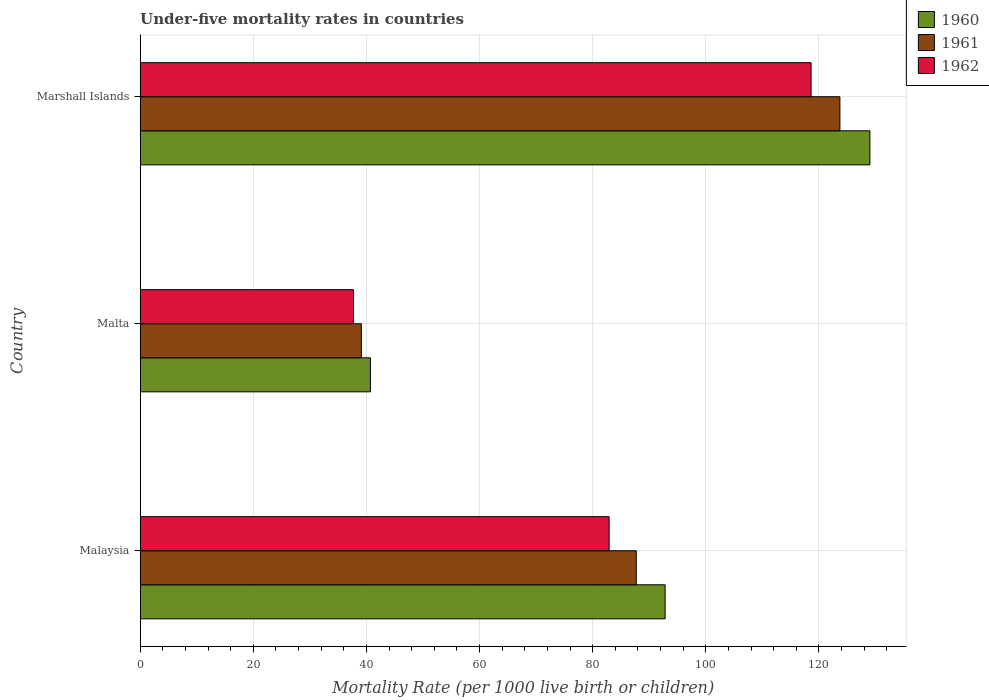How many different coloured bars are there?
Provide a succinct answer. 3. How many groups of bars are there?
Provide a succinct answer. 3. Are the number of bars per tick equal to the number of legend labels?
Give a very brief answer. Yes. How many bars are there on the 1st tick from the bottom?
Your answer should be compact. 3. What is the label of the 3rd group of bars from the top?
Provide a short and direct response. Malaysia. In how many cases, is the number of bars for a given country not equal to the number of legend labels?
Provide a short and direct response. 0. What is the under-five mortality rate in 1960 in Malta?
Offer a terse response. 40.7. Across all countries, what is the maximum under-five mortality rate in 1961?
Make the answer very short. 123.7. Across all countries, what is the minimum under-five mortality rate in 1962?
Give a very brief answer. 37.7. In which country was the under-five mortality rate in 1961 maximum?
Give a very brief answer. Marshall Islands. In which country was the under-five mortality rate in 1961 minimum?
Give a very brief answer. Malta. What is the total under-five mortality rate in 1962 in the graph?
Your answer should be compact. 239.2. What is the difference between the under-five mortality rate in 1960 in Malta and that in Marshall Islands?
Your response must be concise. -88.3. What is the difference between the under-five mortality rate in 1961 in Marshall Islands and the under-five mortality rate in 1960 in Malaysia?
Offer a terse response. 30.9. What is the average under-five mortality rate in 1960 per country?
Offer a terse response. 87.5. What is the difference between the under-five mortality rate in 1961 and under-five mortality rate in 1960 in Malaysia?
Provide a short and direct response. -5.1. What is the ratio of the under-five mortality rate in 1962 in Malaysia to that in Malta?
Give a very brief answer. 2.2. What is the difference between the highest and the second highest under-five mortality rate in 1960?
Give a very brief answer. 36.2. What is the difference between the highest and the lowest under-five mortality rate in 1962?
Offer a very short reply. 80.9. Is the sum of the under-five mortality rate in 1960 in Malaysia and Marshall Islands greater than the maximum under-five mortality rate in 1962 across all countries?
Make the answer very short. Yes. How many bars are there?
Provide a succinct answer. 9. Are all the bars in the graph horizontal?
Offer a very short reply. Yes. Are the values on the major ticks of X-axis written in scientific E-notation?
Your answer should be compact. No. Does the graph contain any zero values?
Provide a succinct answer. No. What is the title of the graph?
Offer a terse response. Under-five mortality rates in countries. Does "1969" appear as one of the legend labels in the graph?
Make the answer very short. No. What is the label or title of the X-axis?
Offer a terse response. Mortality Rate (per 1000 live birth or children). What is the Mortality Rate (per 1000 live birth or children) of 1960 in Malaysia?
Your answer should be compact. 92.8. What is the Mortality Rate (per 1000 live birth or children) in 1961 in Malaysia?
Your response must be concise. 87.7. What is the Mortality Rate (per 1000 live birth or children) of 1962 in Malaysia?
Your response must be concise. 82.9. What is the Mortality Rate (per 1000 live birth or children) in 1960 in Malta?
Your response must be concise. 40.7. What is the Mortality Rate (per 1000 live birth or children) of 1961 in Malta?
Make the answer very short. 39.1. What is the Mortality Rate (per 1000 live birth or children) in 1962 in Malta?
Offer a very short reply. 37.7. What is the Mortality Rate (per 1000 live birth or children) of 1960 in Marshall Islands?
Your answer should be very brief. 129. What is the Mortality Rate (per 1000 live birth or children) in 1961 in Marshall Islands?
Keep it short and to the point. 123.7. What is the Mortality Rate (per 1000 live birth or children) in 1962 in Marshall Islands?
Offer a terse response. 118.6. Across all countries, what is the maximum Mortality Rate (per 1000 live birth or children) in 1960?
Offer a very short reply. 129. Across all countries, what is the maximum Mortality Rate (per 1000 live birth or children) of 1961?
Offer a terse response. 123.7. Across all countries, what is the maximum Mortality Rate (per 1000 live birth or children) of 1962?
Offer a very short reply. 118.6. Across all countries, what is the minimum Mortality Rate (per 1000 live birth or children) in 1960?
Ensure brevity in your answer.  40.7. Across all countries, what is the minimum Mortality Rate (per 1000 live birth or children) in 1961?
Your answer should be very brief. 39.1. Across all countries, what is the minimum Mortality Rate (per 1000 live birth or children) in 1962?
Provide a short and direct response. 37.7. What is the total Mortality Rate (per 1000 live birth or children) in 1960 in the graph?
Your response must be concise. 262.5. What is the total Mortality Rate (per 1000 live birth or children) of 1961 in the graph?
Give a very brief answer. 250.5. What is the total Mortality Rate (per 1000 live birth or children) of 1962 in the graph?
Keep it short and to the point. 239.2. What is the difference between the Mortality Rate (per 1000 live birth or children) in 1960 in Malaysia and that in Malta?
Your answer should be very brief. 52.1. What is the difference between the Mortality Rate (per 1000 live birth or children) in 1961 in Malaysia and that in Malta?
Provide a succinct answer. 48.6. What is the difference between the Mortality Rate (per 1000 live birth or children) in 1962 in Malaysia and that in Malta?
Offer a very short reply. 45.2. What is the difference between the Mortality Rate (per 1000 live birth or children) in 1960 in Malaysia and that in Marshall Islands?
Offer a terse response. -36.2. What is the difference between the Mortality Rate (per 1000 live birth or children) in 1961 in Malaysia and that in Marshall Islands?
Offer a terse response. -36. What is the difference between the Mortality Rate (per 1000 live birth or children) in 1962 in Malaysia and that in Marshall Islands?
Make the answer very short. -35.7. What is the difference between the Mortality Rate (per 1000 live birth or children) of 1960 in Malta and that in Marshall Islands?
Provide a short and direct response. -88.3. What is the difference between the Mortality Rate (per 1000 live birth or children) in 1961 in Malta and that in Marshall Islands?
Provide a short and direct response. -84.6. What is the difference between the Mortality Rate (per 1000 live birth or children) in 1962 in Malta and that in Marshall Islands?
Make the answer very short. -80.9. What is the difference between the Mortality Rate (per 1000 live birth or children) in 1960 in Malaysia and the Mortality Rate (per 1000 live birth or children) in 1961 in Malta?
Your answer should be very brief. 53.7. What is the difference between the Mortality Rate (per 1000 live birth or children) of 1960 in Malaysia and the Mortality Rate (per 1000 live birth or children) of 1962 in Malta?
Your answer should be compact. 55.1. What is the difference between the Mortality Rate (per 1000 live birth or children) in 1961 in Malaysia and the Mortality Rate (per 1000 live birth or children) in 1962 in Malta?
Provide a short and direct response. 50. What is the difference between the Mortality Rate (per 1000 live birth or children) in 1960 in Malaysia and the Mortality Rate (per 1000 live birth or children) in 1961 in Marshall Islands?
Offer a very short reply. -30.9. What is the difference between the Mortality Rate (per 1000 live birth or children) of 1960 in Malaysia and the Mortality Rate (per 1000 live birth or children) of 1962 in Marshall Islands?
Make the answer very short. -25.8. What is the difference between the Mortality Rate (per 1000 live birth or children) of 1961 in Malaysia and the Mortality Rate (per 1000 live birth or children) of 1962 in Marshall Islands?
Give a very brief answer. -30.9. What is the difference between the Mortality Rate (per 1000 live birth or children) of 1960 in Malta and the Mortality Rate (per 1000 live birth or children) of 1961 in Marshall Islands?
Keep it short and to the point. -83. What is the difference between the Mortality Rate (per 1000 live birth or children) of 1960 in Malta and the Mortality Rate (per 1000 live birth or children) of 1962 in Marshall Islands?
Keep it short and to the point. -77.9. What is the difference between the Mortality Rate (per 1000 live birth or children) of 1961 in Malta and the Mortality Rate (per 1000 live birth or children) of 1962 in Marshall Islands?
Keep it short and to the point. -79.5. What is the average Mortality Rate (per 1000 live birth or children) of 1960 per country?
Provide a succinct answer. 87.5. What is the average Mortality Rate (per 1000 live birth or children) of 1961 per country?
Your response must be concise. 83.5. What is the average Mortality Rate (per 1000 live birth or children) in 1962 per country?
Your response must be concise. 79.73. What is the difference between the Mortality Rate (per 1000 live birth or children) in 1960 and Mortality Rate (per 1000 live birth or children) in 1961 in Malaysia?
Keep it short and to the point. 5.1. What is the difference between the Mortality Rate (per 1000 live birth or children) in 1960 and Mortality Rate (per 1000 live birth or children) in 1962 in Malaysia?
Make the answer very short. 9.9. What is the difference between the Mortality Rate (per 1000 live birth or children) of 1960 and Mortality Rate (per 1000 live birth or children) of 1961 in Malta?
Your response must be concise. 1.6. What is the difference between the Mortality Rate (per 1000 live birth or children) of 1960 and Mortality Rate (per 1000 live birth or children) of 1962 in Malta?
Offer a very short reply. 3. What is the difference between the Mortality Rate (per 1000 live birth or children) in 1961 and Mortality Rate (per 1000 live birth or children) in 1962 in Malta?
Provide a succinct answer. 1.4. What is the difference between the Mortality Rate (per 1000 live birth or children) in 1960 and Mortality Rate (per 1000 live birth or children) in 1962 in Marshall Islands?
Offer a very short reply. 10.4. What is the ratio of the Mortality Rate (per 1000 live birth or children) of 1960 in Malaysia to that in Malta?
Your answer should be compact. 2.28. What is the ratio of the Mortality Rate (per 1000 live birth or children) in 1961 in Malaysia to that in Malta?
Offer a very short reply. 2.24. What is the ratio of the Mortality Rate (per 1000 live birth or children) of 1962 in Malaysia to that in Malta?
Make the answer very short. 2.2. What is the ratio of the Mortality Rate (per 1000 live birth or children) in 1960 in Malaysia to that in Marshall Islands?
Offer a very short reply. 0.72. What is the ratio of the Mortality Rate (per 1000 live birth or children) of 1961 in Malaysia to that in Marshall Islands?
Provide a succinct answer. 0.71. What is the ratio of the Mortality Rate (per 1000 live birth or children) of 1962 in Malaysia to that in Marshall Islands?
Provide a short and direct response. 0.7. What is the ratio of the Mortality Rate (per 1000 live birth or children) of 1960 in Malta to that in Marshall Islands?
Your response must be concise. 0.32. What is the ratio of the Mortality Rate (per 1000 live birth or children) of 1961 in Malta to that in Marshall Islands?
Make the answer very short. 0.32. What is the ratio of the Mortality Rate (per 1000 live birth or children) of 1962 in Malta to that in Marshall Islands?
Your answer should be compact. 0.32. What is the difference between the highest and the second highest Mortality Rate (per 1000 live birth or children) of 1960?
Your response must be concise. 36.2. What is the difference between the highest and the second highest Mortality Rate (per 1000 live birth or children) in 1961?
Your answer should be compact. 36. What is the difference between the highest and the second highest Mortality Rate (per 1000 live birth or children) in 1962?
Your response must be concise. 35.7. What is the difference between the highest and the lowest Mortality Rate (per 1000 live birth or children) in 1960?
Make the answer very short. 88.3. What is the difference between the highest and the lowest Mortality Rate (per 1000 live birth or children) in 1961?
Make the answer very short. 84.6. What is the difference between the highest and the lowest Mortality Rate (per 1000 live birth or children) in 1962?
Your response must be concise. 80.9. 